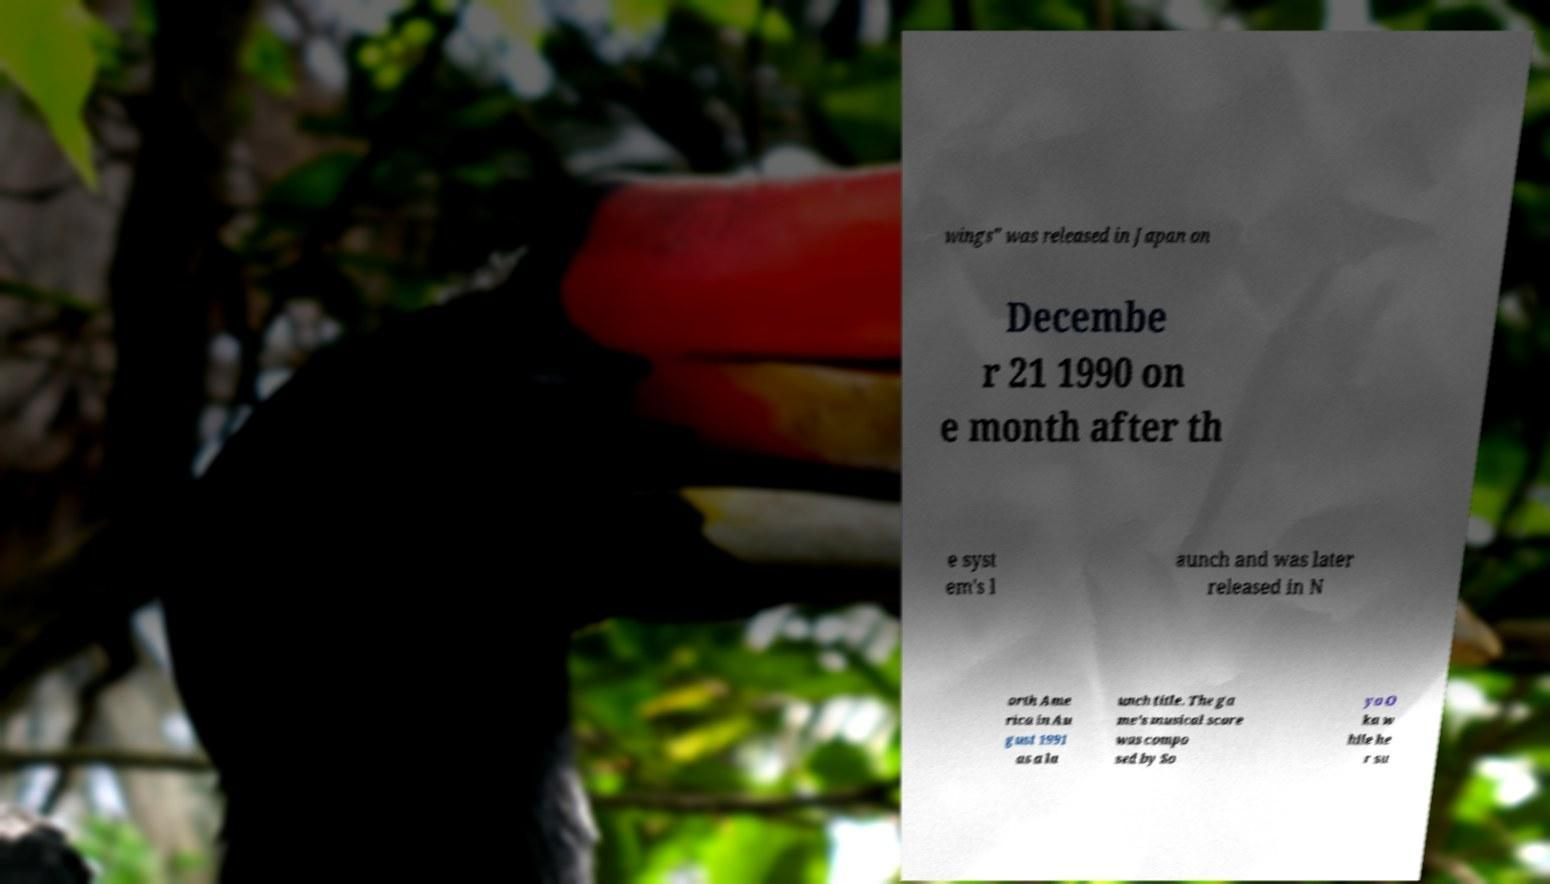Could you assist in decoding the text presented in this image and type it out clearly? wings" was released in Japan on Decembe r 21 1990 on e month after th e syst em's l aunch and was later released in N orth Ame rica in Au gust 1991 as a la unch title. The ga me's musical score was compo sed by So yo O ka w hile he r su 